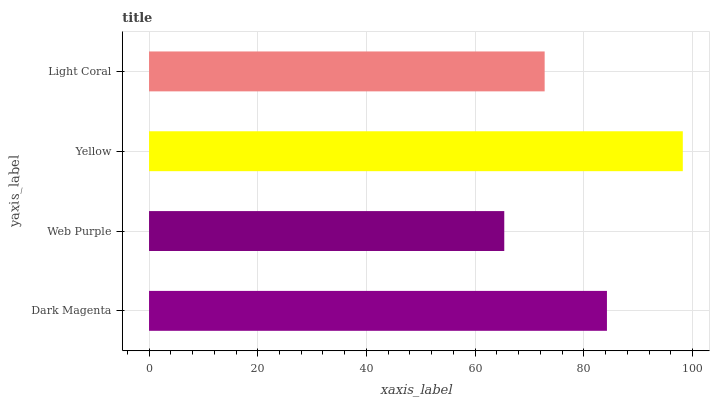Is Web Purple the minimum?
Answer yes or no. Yes. Is Yellow the maximum?
Answer yes or no. Yes. Is Yellow the minimum?
Answer yes or no. No. Is Web Purple the maximum?
Answer yes or no. No. Is Yellow greater than Web Purple?
Answer yes or no. Yes. Is Web Purple less than Yellow?
Answer yes or no. Yes. Is Web Purple greater than Yellow?
Answer yes or no. No. Is Yellow less than Web Purple?
Answer yes or no. No. Is Dark Magenta the high median?
Answer yes or no. Yes. Is Light Coral the low median?
Answer yes or no. Yes. Is Web Purple the high median?
Answer yes or no. No. Is Dark Magenta the low median?
Answer yes or no. No. 